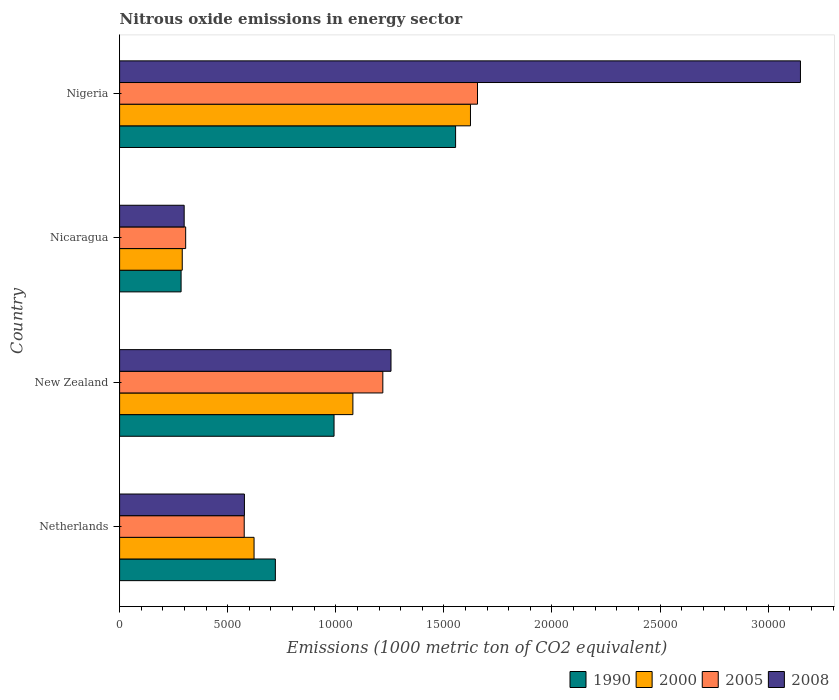Are the number of bars per tick equal to the number of legend labels?
Provide a succinct answer. Yes. Are the number of bars on each tick of the Y-axis equal?
Your answer should be very brief. Yes. How many bars are there on the 4th tick from the bottom?
Provide a succinct answer. 4. In how many cases, is the number of bars for a given country not equal to the number of legend labels?
Give a very brief answer. 0. What is the amount of nitrous oxide emitted in 1990 in New Zealand?
Keep it short and to the point. 9919.5. Across all countries, what is the maximum amount of nitrous oxide emitted in 2008?
Give a very brief answer. 3.15e+04. Across all countries, what is the minimum amount of nitrous oxide emitted in 2005?
Make the answer very short. 3056.1. In which country was the amount of nitrous oxide emitted in 1990 maximum?
Provide a short and direct response. Nigeria. In which country was the amount of nitrous oxide emitted in 2005 minimum?
Ensure brevity in your answer.  Nicaragua. What is the total amount of nitrous oxide emitted in 1990 in the graph?
Offer a terse response. 3.55e+04. What is the difference between the amount of nitrous oxide emitted in 2000 in Netherlands and that in New Zealand?
Offer a terse response. -4571.7. What is the difference between the amount of nitrous oxide emitted in 2005 in Nigeria and the amount of nitrous oxide emitted in 1990 in Nicaragua?
Provide a succinct answer. 1.37e+04. What is the average amount of nitrous oxide emitted in 2005 per country?
Keep it short and to the point. 9388.1. What is the difference between the amount of nitrous oxide emitted in 2008 and amount of nitrous oxide emitted in 2005 in New Zealand?
Make the answer very short. 378.1. What is the ratio of the amount of nitrous oxide emitted in 2005 in Nicaragua to that in Nigeria?
Provide a short and direct response. 0.18. What is the difference between the highest and the second highest amount of nitrous oxide emitted in 1990?
Make the answer very short. 5623. What is the difference between the highest and the lowest amount of nitrous oxide emitted in 1990?
Your response must be concise. 1.27e+04. What does the 3rd bar from the top in New Zealand represents?
Your answer should be very brief. 2000. How many bars are there?
Give a very brief answer. 16. Are all the bars in the graph horizontal?
Ensure brevity in your answer.  Yes. What is the difference between two consecutive major ticks on the X-axis?
Give a very brief answer. 5000. Are the values on the major ticks of X-axis written in scientific E-notation?
Your response must be concise. No. Does the graph contain any zero values?
Offer a terse response. No. How many legend labels are there?
Your response must be concise. 4. How are the legend labels stacked?
Your answer should be compact. Horizontal. What is the title of the graph?
Offer a terse response. Nitrous oxide emissions in energy sector. Does "1979" appear as one of the legend labels in the graph?
Your answer should be compact. No. What is the label or title of the X-axis?
Provide a short and direct response. Emissions (1000 metric ton of CO2 equivalent). What is the Emissions (1000 metric ton of CO2 equivalent) of 1990 in Netherlands?
Provide a short and direct response. 7205. What is the Emissions (1000 metric ton of CO2 equivalent) of 2000 in Netherlands?
Offer a terse response. 6219.5. What is the Emissions (1000 metric ton of CO2 equivalent) of 2005 in Netherlands?
Offer a very short reply. 5764.8. What is the Emissions (1000 metric ton of CO2 equivalent) of 2008 in Netherlands?
Provide a short and direct response. 5773.6. What is the Emissions (1000 metric ton of CO2 equivalent) of 1990 in New Zealand?
Give a very brief answer. 9919.5. What is the Emissions (1000 metric ton of CO2 equivalent) of 2000 in New Zealand?
Your answer should be very brief. 1.08e+04. What is the Emissions (1000 metric ton of CO2 equivalent) in 2005 in New Zealand?
Provide a short and direct response. 1.22e+04. What is the Emissions (1000 metric ton of CO2 equivalent) in 2008 in New Zealand?
Offer a very short reply. 1.26e+04. What is the Emissions (1000 metric ton of CO2 equivalent) in 1990 in Nicaragua?
Make the answer very short. 2844.7. What is the Emissions (1000 metric ton of CO2 equivalent) of 2000 in Nicaragua?
Your answer should be very brief. 2898.2. What is the Emissions (1000 metric ton of CO2 equivalent) of 2005 in Nicaragua?
Give a very brief answer. 3056.1. What is the Emissions (1000 metric ton of CO2 equivalent) of 2008 in Nicaragua?
Your response must be concise. 2986.9. What is the Emissions (1000 metric ton of CO2 equivalent) of 1990 in Nigeria?
Ensure brevity in your answer.  1.55e+04. What is the Emissions (1000 metric ton of CO2 equivalent) of 2000 in Nigeria?
Make the answer very short. 1.62e+04. What is the Emissions (1000 metric ton of CO2 equivalent) of 2005 in Nigeria?
Keep it short and to the point. 1.66e+04. What is the Emissions (1000 metric ton of CO2 equivalent) in 2008 in Nigeria?
Give a very brief answer. 3.15e+04. Across all countries, what is the maximum Emissions (1000 metric ton of CO2 equivalent) of 1990?
Keep it short and to the point. 1.55e+04. Across all countries, what is the maximum Emissions (1000 metric ton of CO2 equivalent) of 2000?
Your answer should be compact. 1.62e+04. Across all countries, what is the maximum Emissions (1000 metric ton of CO2 equivalent) of 2005?
Offer a very short reply. 1.66e+04. Across all countries, what is the maximum Emissions (1000 metric ton of CO2 equivalent) in 2008?
Ensure brevity in your answer.  3.15e+04. Across all countries, what is the minimum Emissions (1000 metric ton of CO2 equivalent) in 1990?
Your answer should be very brief. 2844.7. Across all countries, what is the minimum Emissions (1000 metric ton of CO2 equivalent) in 2000?
Your response must be concise. 2898.2. Across all countries, what is the minimum Emissions (1000 metric ton of CO2 equivalent) in 2005?
Provide a succinct answer. 3056.1. Across all countries, what is the minimum Emissions (1000 metric ton of CO2 equivalent) of 2008?
Ensure brevity in your answer.  2986.9. What is the total Emissions (1000 metric ton of CO2 equivalent) of 1990 in the graph?
Your answer should be compact. 3.55e+04. What is the total Emissions (1000 metric ton of CO2 equivalent) of 2000 in the graph?
Your answer should be very brief. 3.61e+04. What is the total Emissions (1000 metric ton of CO2 equivalent) in 2005 in the graph?
Give a very brief answer. 3.76e+04. What is the total Emissions (1000 metric ton of CO2 equivalent) in 2008 in the graph?
Keep it short and to the point. 5.28e+04. What is the difference between the Emissions (1000 metric ton of CO2 equivalent) in 1990 in Netherlands and that in New Zealand?
Keep it short and to the point. -2714.5. What is the difference between the Emissions (1000 metric ton of CO2 equivalent) in 2000 in Netherlands and that in New Zealand?
Your answer should be compact. -4571.7. What is the difference between the Emissions (1000 metric ton of CO2 equivalent) of 2005 in Netherlands and that in New Zealand?
Offer a very short reply. -6411.2. What is the difference between the Emissions (1000 metric ton of CO2 equivalent) in 2008 in Netherlands and that in New Zealand?
Ensure brevity in your answer.  -6780.5. What is the difference between the Emissions (1000 metric ton of CO2 equivalent) of 1990 in Netherlands and that in Nicaragua?
Provide a succinct answer. 4360.3. What is the difference between the Emissions (1000 metric ton of CO2 equivalent) of 2000 in Netherlands and that in Nicaragua?
Provide a short and direct response. 3321.3. What is the difference between the Emissions (1000 metric ton of CO2 equivalent) in 2005 in Netherlands and that in Nicaragua?
Your answer should be compact. 2708.7. What is the difference between the Emissions (1000 metric ton of CO2 equivalent) of 2008 in Netherlands and that in Nicaragua?
Offer a very short reply. 2786.7. What is the difference between the Emissions (1000 metric ton of CO2 equivalent) in 1990 in Netherlands and that in Nigeria?
Provide a short and direct response. -8337.5. What is the difference between the Emissions (1000 metric ton of CO2 equivalent) of 2000 in Netherlands and that in Nigeria?
Your answer should be compact. -1.00e+04. What is the difference between the Emissions (1000 metric ton of CO2 equivalent) in 2005 in Netherlands and that in Nigeria?
Your answer should be compact. -1.08e+04. What is the difference between the Emissions (1000 metric ton of CO2 equivalent) of 2008 in Netherlands and that in Nigeria?
Give a very brief answer. -2.57e+04. What is the difference between the Emissions (1000 metric ton of CO2 equivalent) of 1990 in New Zealand and that in Nicaragua?
Make the answer very short. 7074.8. What is the difference between the Emissions (1000 metric ton of CO2 equivalent) of 2000 in New Zealand and that in Nicaragua?
Your answer should be very brief. 7893. What is the difference between the Emissions (1000 metric ton of CO2 equivalent) in 2005 in New Zealand and that in Nicaragua?
Make the answer very short. 9119.9. What is the difference between the Emissions (1000 metric ton of CO2 equivalent) in 2008 in New Zealand and that in Nicaragua?
Your response must be concise. 9567.2. What is the difference between the Emissions (1000 metric ton of CO2 equivalent) of 1990 in New Zealand and that in Nigeria?
Provide a short and direct response. -5623. What is the difference between the Emissions (1000 metric ton of CO2 equivalent) of 2000 in New Zealand and that in Nigeria?
Give a very brief answer. -5439.4. What is the difference between the Emissions (1000 metric ton of CO2 equivalent) of 2005 in New Zealand and that in Nigeria?
Ensure brevity in your answer.  -4379.5. What is the difference between the Emissions (1000 metric ton of CO2 equivalent) of 2008 in New Zealand and that in Nigeria?
Offer a terse response. -1.89e+04. What is the difference between the Emissions (1000 metric ton of CO2 equivalent) of 1990 in Nicaragua and that in Nigeria?
Your response must be concise. -1.27e+04. What is the difference between the Emissions (1000 metric ton of CO2 equivalent) of 2000 in Nicaragua and that in Nigeria?
Make the answer very short. -1.33e+04. What is the difference between the Emissions (1000 metric ton of CO2 equivalent) of 2005 in Nicaragua and that in Nigeria?
Your answer should be very brief. -1.35e+04. What is the difference between the Emissions (1000 metric ton of CO2 equivalent) in 2008 in Nicaragua and that in Nigeria?
Your answer should be very brief. -2.85e+04. What is the difference between the Emissions (1000 metric ton of CO2 equivalent) in 1990 in Netherlands and the Emissions (1000 metric ton of CO2 equivalent) in 2000 in New Zealand?
Your response must be concise. -3586.2. What is the difference between the Emissions (1000 metric ton of CO2 equivalent) of 1990 in Netherlands and the Emissions (1000 metric ton of CO2 equivalent) of 2005 in New Zealand?
Keep it short and to the point. -4971. What is the difference between the Emissions (1000 metric ton of CO2 equivalent) in 1990 in Netherlands and the Emissions (1000 metric ton of CO2 equivalent) in 2008 in New Zealand?
Your answer should be very brief. -5349.1. What is the difference between the Emissions (1000 metric ton of CO2 equivalent) in 2000 in Netherlands and the Emissions (1000 metric ton of CO2 equivalent) in 2005 in New Zealand?
Offer a terse response. -5956.5. What is the difference between the Emissions (1000 metric ton of CO2 equivalent) in 2000 in Netherlands and the Emissions (1000 metric ton of CO2 equivalent) in 2008 in New Zealand?
Ensure brevity in your answer.  -6334.6. What is the difference between the Emissions (1000 metric ton of CO2 equivalent) in 2005 in Netherlands and the Emissions (1000 metric ton of CO2 equivalent) in 2008 in New Zealand?
Provide a short and direct response. -6789.3. What is the difference between the Emissions (1000 metric ton of CO2 equivalent) in 1990 in Netherlands and the Emissions (1000 metric ton of CO2 equivalent) in 2000 in Nicaragua?
Offer a terse response. 4306.8. What is the difference between the Emissions (1000 metric ton of CO2 equivalent) of 1990 in Netherlands and the Emissions (1000 metric ton of CO2 equivalent) of 2005 in Nicaragua?
Ensure brevity in your answer.  4148.9. What is the difference between the Emissions (1000 metric ton of CO2 equivalent) in 1990 in Netherlands and the Emissions (1000 metric ton of CO2 equivalent) in 2008 in Nicaragua?
Your answer should be compact. 4218.1. What is the difference between the Emissions (1000 metric ton of CO2 equivalent) in 2000 in Netherlands and the Emissions (1000 metric ton of CO2 equivalent) in 2005 in Nicaragua?
Make the answer very short. 3163.4. What is the difference between the Emissions (1000 metric ton of CO2 equivalent) in 2000 in Netherlands and the Emissions (1000 metric ton of CO2 equivalent) in 2008 in Nicaragua?
Ensure brevity in your answer.  3232.6. What is the difference between the Emissions (1000 metric ton of CO2 equivalent) of 2005 in Netherlands and the Emissions (1000 metric ton of CO2 equivalent) of 2008 in Nicaragua?
Give a very brief answer. 2777.9. What is the difference between the Emissions (1000 metric ton of CO2 equivalent) in 1990 in Netherlands and the Emissions (1000 metric ton of CO2 equivalent) in 2000 in Nigeria?
Offer a terse response. -9025.6. What is the difference between the Emissions (1000 metric ton of CO2 equivalent) in 1990 in Netherlands and the Emissions (1000 metric ton of CO2 equivalent) in 2005 in Nigeria?
Your answer should be compact. -9350.5. What is the difference between the Emissions (1000 metric ton of CO2 equivalent) in 1990 in Netherlands and the Emissions (1000 metric ton of CO2 equivalent) in 2008 in Nigeria?
Give a very brief answer. -2.43e+04. What is the difference between the Emissions (1000 metric ton of CO2 equivalent) of 2000 in Netherlands and the Emissions (1000 metric ton of CO2 equivalent) of 2005 in Nigeria?
Provide a succinct answer. -1.03e+04. What is the difference between the Emissions (1000 metric ton of CO2 equivalent) of 2000 in Netherlands and the Emissions (1000 metric ton of CO2 equivalent) of 2008 in Nigeria?
Ensure brevity in your answer.  -2.53e+04. What is the difference between the Emissions (1000 metric ton of CO2 equivalent) of 2005 in Netherlands and the Emissions (1000 metric ton of CO2 equivalent) of 2008 in Nigeria?
Provide a short and direct response. -2.57e+04. What is the difference between the Emissions (1000 metric ton of CO2 equivalent) in 1990 in New Zealand and the Emissions (1000 metric ton of CO2 equivalent) in 2000 in Nicaragua?
Offer a terse response. 7021.3. What is the difference between the Emissions (1000 metric ton of CO2 equivalent) in 1990 in New Zealand and the Emissions (1000 metric ton of CO2 equivalent) in 2005 in Nicaragua?
Provide a short and direct response. 6863.4. What is the difference between the Emissions (1000 metric ton of CO2 equivalent) of 1990 in New Zealand and the Emissions (1000 metric ton of CO2 equivalent) of 2008 in Nicaragua?
Make the answer very short. 6932.6. What is the difference between the Emissions (1000 metric ton of CO2 equivalent) in 2000 in New Zealand and the Emissions (1000 metric ton of CO2 equivalent) in 2005 in Nicaragua?
Provide a succinct answer. 7735.1. What is the difference between the Emissions (1000 metric ton of CO2 equivalent) in 2000 in New Zealand and the Emissions (1000 metric ton of CO2 equivalent) in 2008 in Nicaragua?
Provide a short and direct response. 7804.3. What is the difference between the Emissions (1000 metric ton of CO2 equivalent) of 2005 in New Zealand and the Emissions (1000 metric ton of CO2 equivalent) of 2008 in Nicaragua?
Ensure brevity in your answer.  9189.1. What is the difference between the Emissions (1000 metric ton of CO2 equivalent) in 1990 in New Zealand and the Emissions (1000 metric ton of CO2 equivalent) in 2000 in Nigeria?
Provide a short and direct response. -6311.1. What is the difference between the Emissions (1000 metric ton of CO2 equivalent) of 1990 in New Zealand and the Emissions (1000 metric ton of CO2 equivalent) of 2005 in Nigeria?
Make the answer very short. -6636. What is the difference between the Emissions (1000 metric ton of CO2 equivalent) in 1990 in New Zealand and the Emissions (1000 metric ton of CO2 equivalent) in 2008 in Nigeria?
Provide a succinct answer. -2.16e+04. What is the difference between the Emissions (1000 metric ton of CO2 equivalent) of 2000 in New Zealand and the Emissions (1000 metric ton of CO2 equivalent) of 2005 in Nigeria?
Your answer should be very brief. -5764.3. What is the difference between the Emissions (1000 metric ton of CO2 equivalent) in 2000 in New Zealand and the Emissions (1000 metric ton of CO2 equivalent) in 2008 in Nigeria?
Your answer should be very brief. -2.07e+04. What is the difference between the Emissions (1000 metric ton of CO2 equivalent) in 2005 in New Zealand and the Emissions (1000 metric ton of CO2 equivalent) in 2008 in Nigeria?
Provide a short and direct response. -1.93e+04. What is the difference between the Emissions (1000 metric ton of CO2 equivalent) in 1990 in Nicaragua and the Emissions (1000 metric ton of CO2 equivalent) in 2000 in Nigeria?
Your answer should be very brief. -1.34e+04. What is the difference between the Emissions (1000 metric ton of CO2 equivalent) in 1990 in Nicaragua and the Emissions (1000 metric ton of CO2 equivalent) in 2005 in Nigeria?
Provide a succinct answer. -1.37e+04. What is the difference between the Emissions (1000 metric ton of CO2 equivalent) in 1990 in Nicaragua and the Emissions (1000 metric ton of CO2 equivalent) in 2008 in Nigeria?
Make the answer very short. -2.86e+04. What is the difference between the Emissions (1000 metric ton of CO2 equivalent) of 2000 in Nicaragua and the Emissions (1000 metric ton of CO2 equivalent) of 2005 in Nigeria?
Offer a terse response. -1.37e+04. What is the difference between the Emissions (1000 metric ton of CO2 equivalent) of 2000 in Nicaragua and the Emissions (1000 metric ton of CO2 equivalent) of 2008 in Nigeria?
Your answer should be very brief. -2.86e+04. What is the difference between the Emissions (1000 metric ton of CO2 equivalent) in 2005 in Nicaragua and the Emissions (1000 metric ton of CO2 equivalent) in 2008 in Nigeria?
Make the answer very short. -2.84e+04. What is the average Emissions (1000 metric ton of CO2 equivalent) of 1990 per country?
Your answer should be very brief. 8877.92. What is the average Emissions (1000 metric ton of CO2 equivalent) in 2000 per country?
Your answer should be compact. 9034.88. What is the average Emissions (1000 metric ton of CO2 equivalent) in 2005 per country?
Ensure brevity in your answer.  9388.1. What is the average Emissions (1000 metric ton of CO2 equivalent) in 2008 per country?
Make the answer very short. 1.32e+04. What is the difference between the Emissions (1000 metric ton of CO2 equivalent) of 1990 and Emissions (1000 metric ton of CO2 equivalent) of 2000 in Netherlands?
Give a very brief answer. 985.5. What is the difference between the Emissions (1000 metric ton of CO2 equivalent) of 1990 and Emissions (1000 metric ton of CO2 equivalent) of 2005 in Netherlands?
Offer a very short reply. 1440.2. What is the difference between the Emissions (1000 metric ton of CO2 equivalent) in 1990 and Emissions (1000 metric ton of CO2 equivalent) in 2008 in Netherlands?
Provide a short and direct response. 1431.4. What is the difference between the Emissions (1000 metric ton of CO2 equivalent) of 2000 and Emissions (1000 metric ton of CO2 equivalent) of 2005 in Netherlands?
Your response must be concise. 454.7. What is the difference between the Emissions (1000 metric ton of CO2 equivalent) of 2000 and Emissions (1000 metric ton of CO2 equivalent) of 2008 in Netherlands?
Provide a succinct answer. 445.9. What is the difference between the Emissions (1000 metric ton of CO2 equivalent) of 1990 and Emissions (1000 metric ton of CO2 equivalent) of 2000 in New Zealand?
Offer a terse response. -871.7. What is the difference between the Emissions (1000 metric ton of CO2 equivalent) in 1990 and Emissions (1000 metric ton of CO2 equivalent) in 2005 in New Zealand?
Your response must be concise. -2256.5. What is the difference between the Emissions (1000 metric ton of CO2 equivalent) in 1990 and Emissions (1000 metric ton of CO2 equivalent) in 2008 in New Zealand?
Your response must be concise. -2634.6. What is the difference between the Emissions (1000 metric ton of CO2 equivalent) of 2000 and Emissions (1000 metric ton of CO2 equivalent) of 2005 in New Zealand?
Give a very brief answer. -1384.8. What is the difference between the Emissions (1000 metric ton of CO2 equivalent) of 2000 and Emissions (1000 metric ton of CO2 equivalent) of 2008 in New Zealand?
Offer a terse response. -1762.9. What is the difference between the Emissions (1000 metric ton of CO2 equivalent) of 2005 and Emissions (1000 metric ton of CO2 equivalent) of 2008 in New Zealand?
Your answer should be very brief. -378.1. What is the difference between the Emissions (1000 metric ton of CO2 equivalent) in 1990 and Emissions (1000 metric ton of CO2 equivalent) in 2000 in Nicaragua?
Your answer should be compact. -53.5. What is the difference between the Emissions (1000 metric ton of CO2 equivalent) of 1990 and Emissions (1000 metric ton of CO2 equivalent) of 2005 in Nicaragua?
Your response must be concise. -211.4. What is the difference between the Emissions (1000 metric ton of CO2 equivalent) of 1990 and Emissions (1000 metric ton of CO2 equivalent) of 2008 in Nicaragua?
Keep it short and to the point. -142.2. What is the difference between the Emissions (1000 metric ton of CO2 equivalent) of 2000 and Emissions (1000 metric ton of CO2 equivalent) of 2005 in Nicaragua?
Your answer should be very brief. -157.9. What is the difference between the Emissions (1000 metric ton of CO2 equivalent) in 2000 and Emissions (1000 metric ton of CO2 equivalent) in 2008 in Nicaragua?
Your answer should be very brief. -88.7. What is the difference between the Emissions (1000 metric ton of CO2 equivalent) in 2005 and Emissions (1000 metric ton of CO2 equivalent) in 2008 in Nicaragua?
Make the answer very short. 69.2. What is the difference between the Emissions (1000 metric ton of CO2 equivalent) in 1990 and Emissions (1000 metric ton of CO2 equivalent) in 2000 in Nigeria?
Keep it short and to the point. -688.1. What is the difference between the Emissions (1000 metric ton of CO2 equivalent) in 1990 and Emissions (1000 metric ton of CO2 equivalent) in 2005 in Nigeria?
Ensure brevity in your answer.  -1013. What is the difference between the Emissions (1000 metric ton of CO2 equivalent) in 1990 and Emissions (1000 metric ton of CO2 equivalent) in 2008 in Nigeria?
Provide a succinct answer. -1.60e+04. What is the difference between the Emissions (1000 metric ton of CO2 equivalent) of 2000 and Emissions (1000 metric ton of CO2 equivalent) of 2005 in Nigeria?
Keep it short and to the point. -324.9. What is the difference between the Emissions (1000 metric ton of CO2 equivalent) in 2000 and Emissions (1000 metric ton of CO2 equivalent) in 2008 in Nigeria?
Ensure brevity in your answer.  -1.53e+04. What is the difference between the Emissions (1000 metric ton of CO2 equivalent) in 2005 and Emissions (1000 metric ton of CO2 equivalent) in 2008 in Nigeria?
Offer a very short reply. -1.49e+04. What is the ratio of the Emissions (1000 metric ton of CO2 equivalent) in 1990 in Netherlands to that in New Zealand?
Ensure brevity in your answer.  0.73. What is the ratio of the Emissions (1000 metric ton of CO2 equivalent) of 2000 in Netherlands to that in New Zealand?
Provide a short and direct response. 0.58. What is the ratio of the Emissions (1000 metric ton of CO2 equivalent) of 2005 in Netherlands to that in New Zealand?
Provide a succinct answer. 0.47. What is the ratio of the Emissions (1000 metric ton of CO2 equivalent) in 2008 in Netherlands to that in New Zealand?
Offer a very short reply. 0.46. What is the ratio of the Emissions (1000 metric ton of CO2 equivalent) of 1990 in Netherlands to that in Nicaragua?
Make the answer very short. 2.53. What is the ratio of the Emissions (1000 metric ton of CO2 equivalent) of 2000 in Netherlands to that in Nicaragua?
Provide a succinct answer. 2.15. What is the ratio of the Emissions (1000 metric ton of CO2 equivalent) of 2005 in Netherlands to that in Nicaragua?
Provide a succinct answer. 1.89. What is the ratio of the Emissions (1000 metric ton of CO2 equivalent) in 2008 in Netherlands to that in Nicaragua?
Give a very brief answer. 1.93. What is the ratio of the Emissions (1000 metric ton of CO2 equivalent) in 1990 in Netherlands to that in Nigeria?
Offer a terse response. 0.46. What is the ratio of the Emissions (1000 metric ton of CO2 equivalent) in 2000 in Netherlands to that in Nigeria?
Provide a short and direct response. 0.38. What is the ratio of the Emissions (1000 metric ton of CO2 equivalent) in 2005 in Netherlands to that in Nigeria?
Provide a short and direct response. 0.35. What is the ratio of the Emissions (1000 metric ton of CO2 equivalent) in 2008 in Netherlands to that in Nigeria?
Your answer should be very brief. 0.18. What is the ratio of the Emissions (1000 metric ton of CO2 equivalent) of 1990 in New Zealand to that in Nicaragua?
Offer a terse response. 3.49. What is the ratio of the Emissions (1000 metric ton of CO2 equivalent) of 2000 in New Zealand to that in Nicaragua?
Your answer should be very brief. 3.72. What is the ratio of the Emissions (1000 metric ton of CO2 equivalent) of 2005 in New Zealand to that in Nicaragua?
Keep it short and to the point. 3.98. What is the ratio of the Emissions (1000 metric ton of CO2 equivalent) in 2008 in New Zealand to that in Nicaragua?
Make the answer very short. 4.2. What is the ratio of the Emissions (1000 metric ton of CO2 equivalent) in 1990 in New Zealand to that in Nigeria?
Your answer should be compact. 0.64. What is the ratio of the Emissions (1000 metric ton of CO2 equivalent) in 2000 in New Zealand to that in Nigeria?
Offer a terse response. 0.66. What is the ratio of the Emissions (1000 metric ton of CO2 equivalent) in 2005 in New Zealand to that in Nigeria?
Your answer should be compact. 0.74. What is the ratio of the Emissions (1000 metric ton of CO2 equivalent) in 2008 in New Zealand to that in Nigeria?
Ensure brevity in your answer.  0.4. What is the ratio of the Emissions (1000 metric ton of CO2 equivalent) of 1990 in Nicaragua to that in Nigeria?
Your response must be concise. 0.18. What is the ratio of the Emissions (1000 metric ton of CO2 equivalent) of 2000 in Nicaragua to that in Nigeria?
Ensure brevity in your answer.  0.18. What is the ratio of the Emissions (1000 metric ton of CO2 equivalent) of 2005 in Nicaragua to that in Nigeria?
Offer a terse response. 0.18. What is the ratio of the Emissions (1000 metric ton of CO2 equivalent) of 2008 in Nicaragua to that in Nigeria?
Your answer should be very brief. 0.09. What is the difference between the highest and the second highest Emissions (1000 metric ton of CO2 equivalent) of 1990?
Your answer should be very brief. 5623. What is the difference between the highest and the second highest Emissions (1000 metric ton of CO2 equivalent) in 2000?
Your response must be concise. 5439.4. What is the difference between the highest and the second highest Emissions (1000 metric ton of CO2 equivalent) in 2005?
Offer a very short reply. 4379.5. What is the difference between the highest and the second highest Emissions (1000 metric ton of CO2 equivalent) of 2008?
Offer a terse response. 1.89e+04. What is the difference between the highest and the lowest Emissions (1000 metric ton of CO2 equivalent) in 1990?
Offer a very short reply. 1.27e+04. What is the difference between the highest and the lowest Emissions (1000 metric ton of CO2 equivalent) in 2000?
Offer a terse response. 1.33e+04. What is the difference between the highest and the lowest Emissions (1000 metric ton of CO2 equivalent) of 2005?
Provide a succinct answer. 1.35e+04. What is the difference between the highest and the lowest Emissions (1000 metric ton of CO2 equivalent) in 2008?
Give a very brief answer. 2.85e+04. 